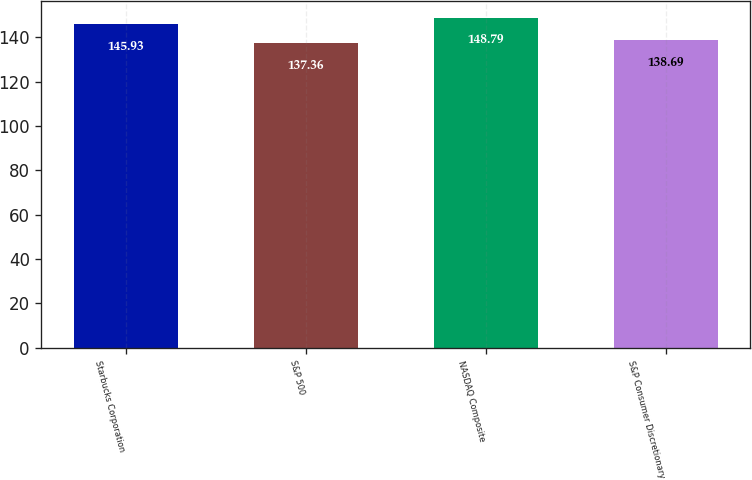<chart> <loc_0><loc_0><loc_500><loc_500><bar_chart><fcel>Starbucks Corporation<fcel>S&P 500<fcel>NASDAQ Composite<fcel>S&P Consumer Discretionary<nl><fcel>145.93<fcel>137.36<fcel>148.79<fcel>138.69<nl></chart> 